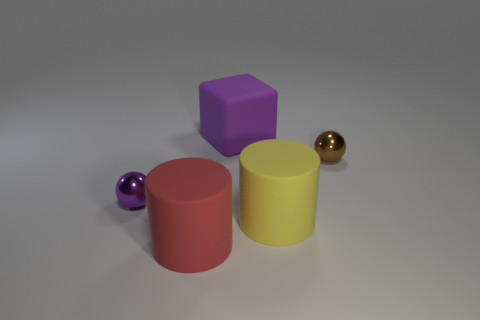The big cube is what color?
Keep it short and to the point. Purple. Is there any other thing of the same color as the large rubber cube?
Ensure brevity in your answer.  Yes. What color is the big object that is both in front of the small brown metal object and right of the red matte object?
Provide a short and direct response. Yellow. Does the metal object in front of the brown thing have the same size as the large red thing?
Your answer should be very brief. No. Is the number of yellow matte cylinders that are behind the purple matte object greater than the number of small green rubber balls?
Offer a terse response. No. Does the purple matte thing have the same shape as the brown metallic thing?
Ensure brevity in your answer.  No. The purple shiny object has what size?
Provide a short and direct response. Small. Are there more large matte cubes in front of the yellow rubber cylinder than yellow things behind the big purple matte object?
Give a very brief answer. No. There is a big purple block; are there any big purple rubber cubes behind it?
Make the answer very short. No. Is there a red rubber object of the same size as the purple block?
Make the answer very short. Yes. 